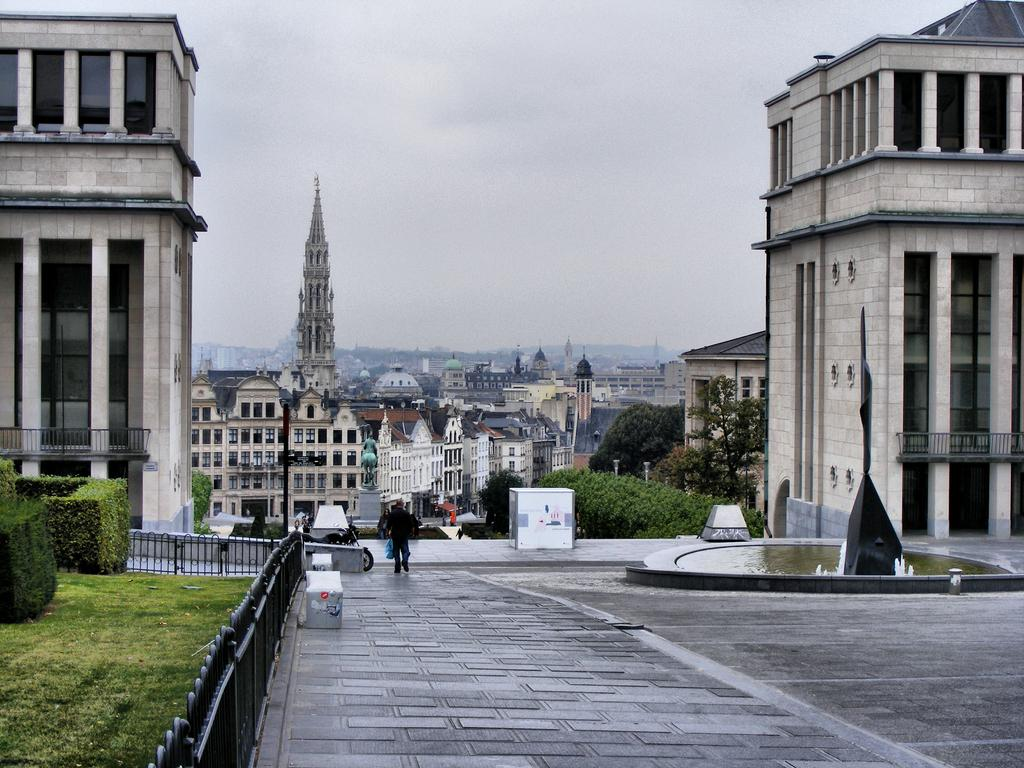What type of structures are present in the image? There are buildings in the image. Can you describe the colors of the buildings? The buildings are in cream and brown colors. What is the person in the image doing? The person is walking in the image. What is the person wearing? The person is wearing a black dress. What type of vegetation can be seen in the image? There are trees in the image. What is the color of the trees? The trees are green. What part of the natural environment is visible in the image? The sky is visible in the image. What is the color of the sky? The sky is in a white color. Where is the team practicing in the image? There is no team or practice visible in the image. What type of hall is shown in the image? There is no hall present in the image. 